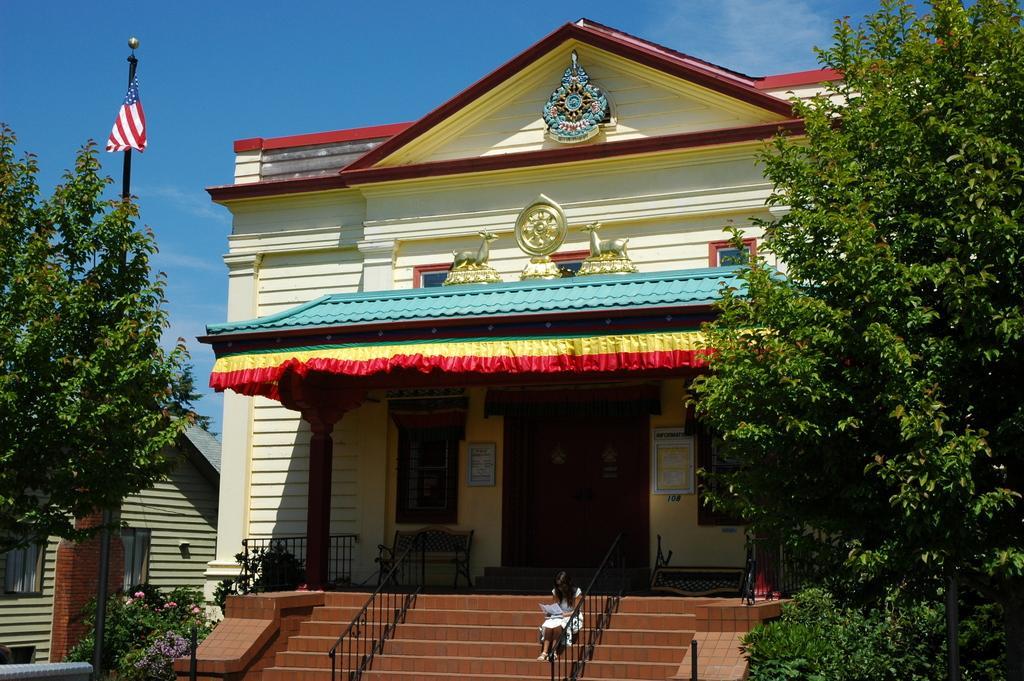Can you describe this image briefly? In this picture we can see a yellow building in the front. On the bottom side we can see some brown steps and a woman sitting and looking into the papers. On both sides there are some trees. On the top we can see the clear blue sky.  